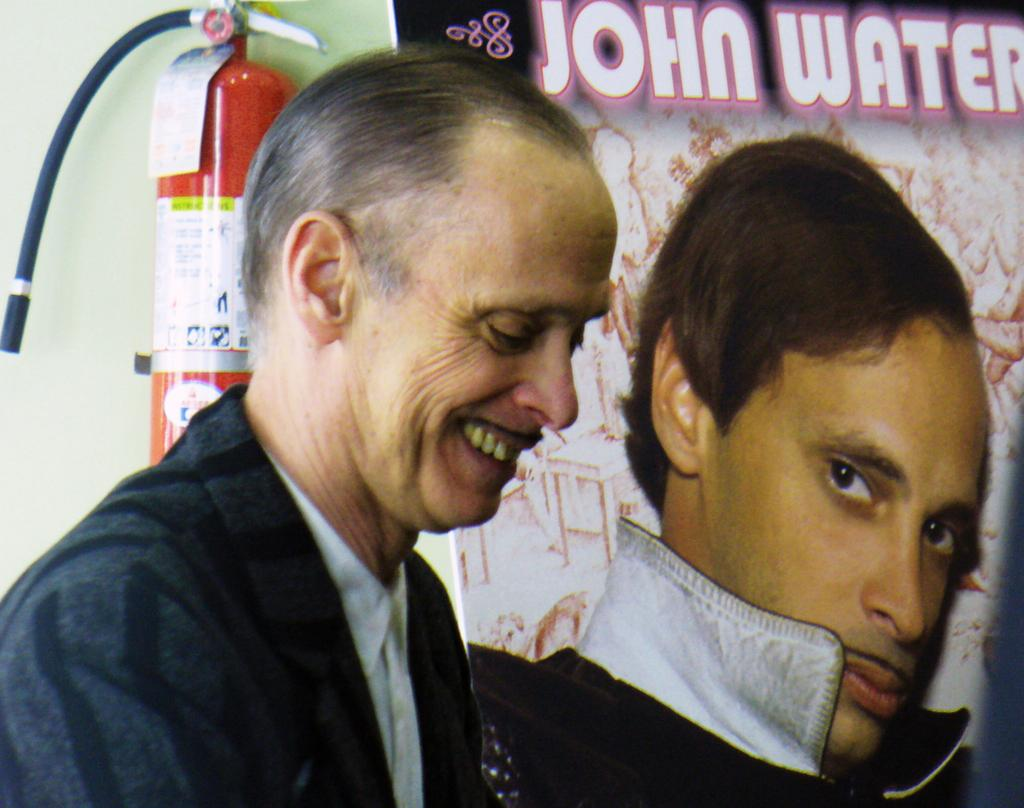Who is present in the image? There is a person in the image. What is the person doing in the image? The person is smiling. What can be seen in the background of the image? There is a banner and an oxygen cylinder on the wall in the background of the image. What type of statement is the person holding in their hands in the image? There is no statement visible in the person's hands in the image. What is the person doing with the yam in the image? There is no yam present in the image. 